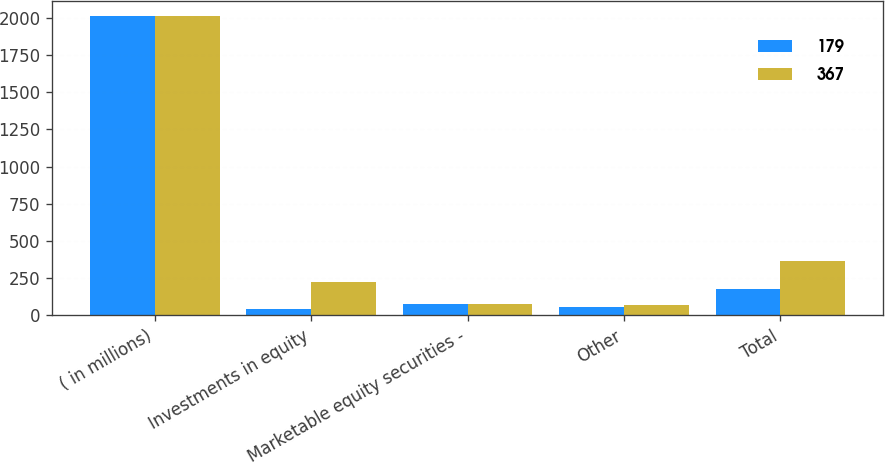Convert chart. <chart><loc_0><loc_0><loc_500><loc_500><stacked_bar_chart><ecel><fcel>( in millions)<fcel>Investments in equity<fcel>Marketable equity securities -<fcel>Other<fcel>Total<nl><fcel>179<fcel>2016<fcel>46<fcel>78<fcel>55<fcel>179<nl><fcel>367<fcel>2015<fcel>221<fcel>77<fcel>69<fcel>367<nl></chart> 